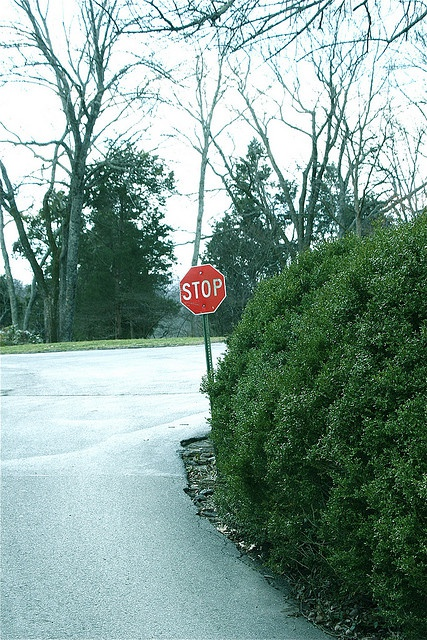Describe the objects in this image and their specific colors. I can see a stop sign in white and brown tones in this image. 